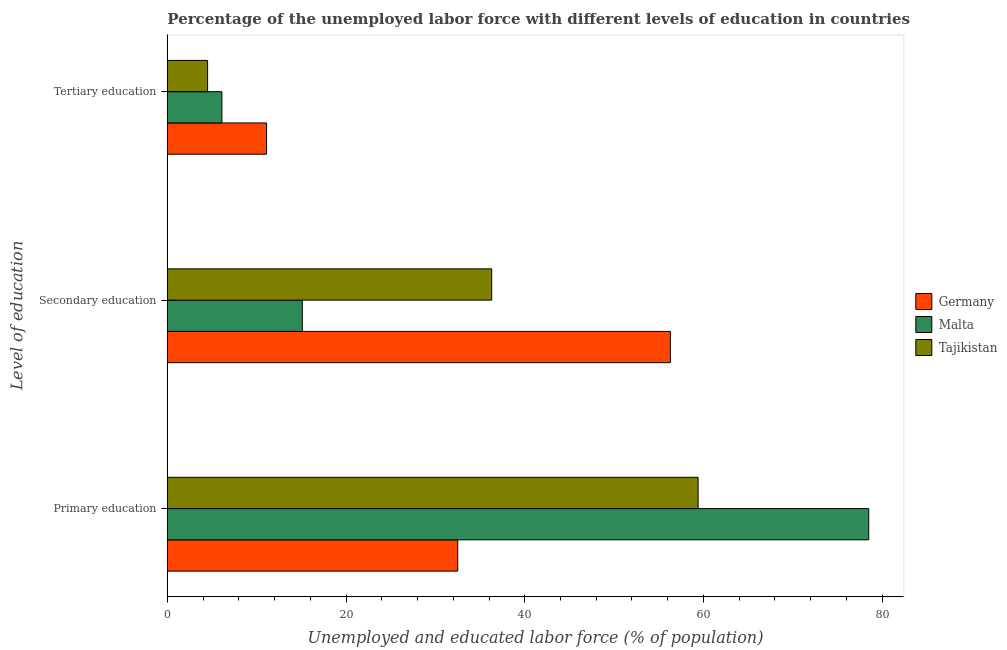Are the number of bars per tick equal to the number of legend labels?
Give a very brief answer. Yes. What is the label of the 1st group of bars from the top?
Provide a short and direct response. Tertiary education. What is the percentage of labor force who received tertiary education in Tajikistan?
Provide a succinct answer. 4.5. Across all countries, what is the maximum percentage of labor force who received tertiary education?
Provide a succinct answer. 11.1. Across all countries, what is the minimum percentage of labor force who received primary education?
Keep it short and to the point. 32.5. In which country was the percentage of labor force who received secondary education maximum?
Keep it short and to the point. Germany. In which country was the percentage of labor force who received secondary education minimum?
Ensure brevity in your answer.  Malta. What is the total percentage of labor force who received primary education in the graph?
Provide a short and direct response. 170.4. What is the difference between the percentage of labor force who received secondary education in Malta and that in Germany?
Offer a very short reply. -41.2. What is the difference between the percentage of labor force who received primary education in Germany and the percentage of labor force who received secondary education in Malta?
Your response must be concise. 17.4. What is the average percentage of labor force who received primary education per country?
Provide a short and direct response. 56.8. What is the difference between the percentage of labor force who received secondary education and percentage of labor force who received tertiary education in Malta?
Offer a terse response. 9. What is the ratio of the percentage of labor force who received tertiary education in Malta to that in Germany?
Offer a very short reply. 0.55. Is the percentage of labor force who received secondary education in Germany less than that in Tajikistan?
Provide a succinct answer. No. Is the difference between the percentage of labor force who received secondary education in Tajikistan and Germany greater than the difference between the percentage of labor force who received primary education in Tajikistan and Germany?
Your response must be concise. No. What is the difference between the highest and the second highest percentage of labor force who received tertiary education?
Keep it short and to the point. 5. What is the difference between the highest and the lowest percentage of labor force who received secondary education?
Give a very brief answer. 41.2. Is the sum of the percentage of labor force who received primary education in Germany and Tajikistan greater than the maximum percentage of labor force who received secondary education across all countries?
Offer a very short reply. Yes. What does the 1st bar from the top in Tertiary education represents?
Your response must be concise. Tajikistan. What does the 2nd bar from the bottom in Primary education represents?
Provide a succinct answer. Malta. How many bars are there?
Provide a succinct answer. 9. Are all the bars in the graph horizontal?
Keep it short and to the point. Yes. How many countries are there in the graph?
Provide a succinct answer. 3. What is the difference between two consecutive major ticks on the X-axis?
Keep it short and to the point. 20. Where does the legend appear in the graph?
Your answer should be very brief. Center right. How many legend labels are there?
Your answer should be compact. 3. What is the title of the graph?
Offer a terse response. Percentage of the unemployed labor force with different levels of education in countries. Does "Cameroon" appear as one of the legend labels in the graph?
Your answer should be compact. No. What is the label or title of the X-axis?
Offer a very short reply. Unemployed and educated labor force (% of population). What is the label or title of the Y-axis?
Make the answer very short. Level of education. What is the Unemployed and educated labor force (% of population) in Germany in Primary education?
Offer a terse response. 32.5. What is the Unemployed and educated labor force (% of population) of Malta in Primary education?
Ensure brevity in your answer.  78.5. What is the Unemployed and educated labor force (% of population) in Tajikistan in Primary education?
Your answer should be very brief. 59.4. What is the Unemployed and educated labor force (% of population) in Germany in Secondary education?
Ensure brevity in your answer.  56.3. What is the Unemployed and educated labor force (% of population) in Malta in Secondary education?
Provide a short and direct response. 15.1. What is the Unemployed and educated labor force (% of population) in Tajikistan in Secondary education?
Offer a very short reply. 36.3. What is the Unemployed and educated labor force (% of population) of Germany in Tertiary education?
Give a very brief answer. 11.1. What is the Unemployed and educated labor force (% of population) of Malta in Tertiary education?
Offer a terse response. 6.1. What is the Unemployed and educated labor force (% of population) in Tajikistan in Tertiary education?
Your answer should be very brief. 4.5. Across all Level of education, what is the maximum Unemployed and educated labor force (% of population) of Germany?
Offer a very short reply. 56.3. Across all Level of education, what is the maximum Unemployed and educated labor force (% of population) in Malta?
Keep it short and to the point. 78.5. Across all Level of education, what is the maximum Unemployed and educated labor force (% of population) of Tajikistan?
Your answer should be very brief. 59.4. Across all Level of education, what is the minimum Unemployed and educated labor force (% of population) in Germany?
Offer a very short reply. 11.1. Across all Level of education, what is the minimum Unemployed and educated labor force (% of population) in Malta?
Provide a succinct answer. 6.1. Across all Level of education, what is the minimum Unemployed and educated labor force (% of population) of Tajikistan?
Provide a succinct answer. 4.5. What is the total Unemployed and educated labor force (% of population) in Germany in the graph?
Keep it short and to the point. 99.9. What is the total Unemployed and educated labor force (% of population) of Malta in the graph?
Ensure brevity in your answer.  99.7. What is the total Unemployed and educated labor force (% of population) of Tajikistan in the graph?
Make the answer very short. 100.2. What is the difference between the Unemployed and educated labor force (% of population) of Germany in Primary education and that in Secondary education?
Provide a succinct answer. -23.8. What is the difference between the Unemployed and educated labor force (% of population) in Malta in Primary education and that in Secondary education?
Provide a succinct answer. 63.4. What is the difference between the Unemployed and educated labor force (% of population) in Tajikistan in Primary education and that in Secondary education?
Your answer should be very brief. 23.1. What is the difference between the Unemployed and educated labor force (% of population) of Germany in Primary education and that in Tertiary education?
Ensure brevity in your answer.  21.4. What is the difference between the Unemployed and educated labor force (% of population) in Malta in Primary education and that in Tertiary education?
Make the answer very short. 72.4. What is the difference between the Unemployed and educated labor force (% of population) of Tajikistan in Primary education and that in Tertiary education?
Give a very brief answer. 54.9. What is the difference between the Unemployed and educated labor force (% of population) in Germany in Secondary education and that in Tertiary education?
Offer a very short reply. 45.2. What is the difference between the Unemployed and educated labor force (% of population) of Malta in Secondary education and that in Tertiary education?
Your answer should be very brief. 9. What is the difference between the Unemployed and educated labor force (% of population) in Tajikistan in Secondary education and that in Tertiary education?
Make the answer very short. 31.8. What is the difference between the Unemployed and educated labor force (% of population) in Germany in Primary education and the Unemployed and educated labor force (% of population) in Tajikistan in Secondary education?
Offer a terse response. -3.8. What is the difference between the Unemployed and educated labor force (% of population) of Malta in Primary education and the Unemployed and educated labor force (% of population) of Tajikistan in Secondary education?
Your answer should be very brief. 42.2. What is the difference between the Unemployed and educated labor force (% of population) in Germany in Primary education and the Unemployed and educated labor force (% of population) in Malta in Tertiary education?
Keep it short and to the point. 26.4. What is the difference between the Unemployed and educated labor force (% of population) in Malta in Primary education and the Unemployed and educated labor force (% of population) in Tajikistan in Tertiary education?
Ensure brevity in your answer.  74. What is the difference between the Unemployed and educated labor force (% of population) of Germany in Secondary education and the Unemployed and educated labor force (% of population) of Malta in Tertiary education?
Your answer should be compact. 50.2. What is the difference between the Unemployed and educated labor force (% of population) in Germany in Secondary education and the Unemployed and educated labor force (% of population) in Tajikistan in Tertiary education?
Keep it short and to the point. 51.8. What is the difference between the Unemployed and educated labor force (% of population) in Malta in Secondary education and the Unemployed and educated labor force (% of population) in Tajikistan in Tertiary education?
Provide a succinct answer. 10.6. What is the average Unemployed and educated labor force (% of population) in Germany per Level of education?
Provide a succinct answer. 33.3. What is the average Unemployed and educated labor force (% of population) in Malta per Level of education?
Your response must be concise. 33.23. What is the average Unemployed and educated labor force (% of population) in Tajikistan per Level of education?
Your answer should be compact. 33.4. What is the difference between the Unemployed and educated labor force (% of population) of Germany and Unemployed and educated labor force (% of population) of Malta in Primary education?
Ensure brevity in your answer.  -46. What is the difference between the Unemployed and educated labor force (% of population) of Germany and Unemployed and educated labor force (% of population) of Tajikistan in Primary education?
Your answer should be compact. -26.9. What is the difference between the Unemployed and educated labor force (% of population) in Malta and Unemployed and educated labor force (% of population) in Tajikistan in Primary education?
Ensure brevity in your answer.  19.1. What is the difference between the Unemployed and educated labor force (% of population) of Germany and Unemployed and educated labor force (% of population) of Malta in Secondary education?
Ensure brevity in your answer.  41.2. What is the difference between the Unemployed and educated labor force (% of population) of Malta and Unemployed and educated labor force (% of population) of Tajikistan in Secondary education?
Offer a terse response. -21.2. What is the difference between the Unemployed and educated labor force (% of population) of Germany and Unemployed and educated labor force (% of population) of Malta in Tertiary education?
Your answer should be compact. 5. What is the ratio of the Unemployed and educated labor force (% of population) in Germany in Primary education to that in Secondary education?
Provide a succinct answer. 0.58. What is the ratio of the Unemployed and educated labor force (% of population) in Malta in Primary education to that in Secondary education?
Provide a short and direct response. 5.2. What is the ratio of the Unemployed and educated labor force (% of population) in Tajikistan in Primary education to that in Secondary education?
Offer a terse response. 1.64. What is the ratio of the Unemployed and educated labor force (% of population) in Germany in Primary education to that in Tertiary education?
Offer a very short reply. 2.93. What is the ratio of the Unemployed and educated labor force (% of population) in Malta in Primary education to that in Tertiary education?
Provide a succinct answer. 12.87. What is the ratio of the Unemployed and educated labor force (% of population) in Germany in Secondary education to that in Tertiary education?
Give a very brief answer. 5.07. What is the ratio of the Unemployed and educated labor force (% of population) of Malta in Secondary education to that in Tertiary education?
Provide a succinct answer. 2.48. What is the ratio of the Unemployed and educated labor force (% of population) in Tajikistan in Secondary education to that in Tertiary education?
Offer a very short reply. 8.07. What is the difference between the highest and the second highest Unemployed and educated labor force (% of population) in Germany?
Provide a succinct answer. 23.8. What is the difference between the highest and the second highest Unemployed and educated labor force (% of population) of Malta?
Your response must be concise. 63.4. What is the difference between the highest and the second highest Unemployed and educated labor force (% of population) of Tajikistan?
Keep it short and to the point. 23.1. What is the difference between the highest and the lowest Unemployed and educated labor force (% of population) in Germany?
Your answer should be compact. 45.2. What is the difference between the highest and the lowest Unemployed and educated labor force (% of population) in Malta?
Ensure brevity in your answer.  72.4. What is the difference between the highest and the lowest Unemployed and educated labor force (% of population) in Tajikistan?
Offer a very short reply. 54.9. 